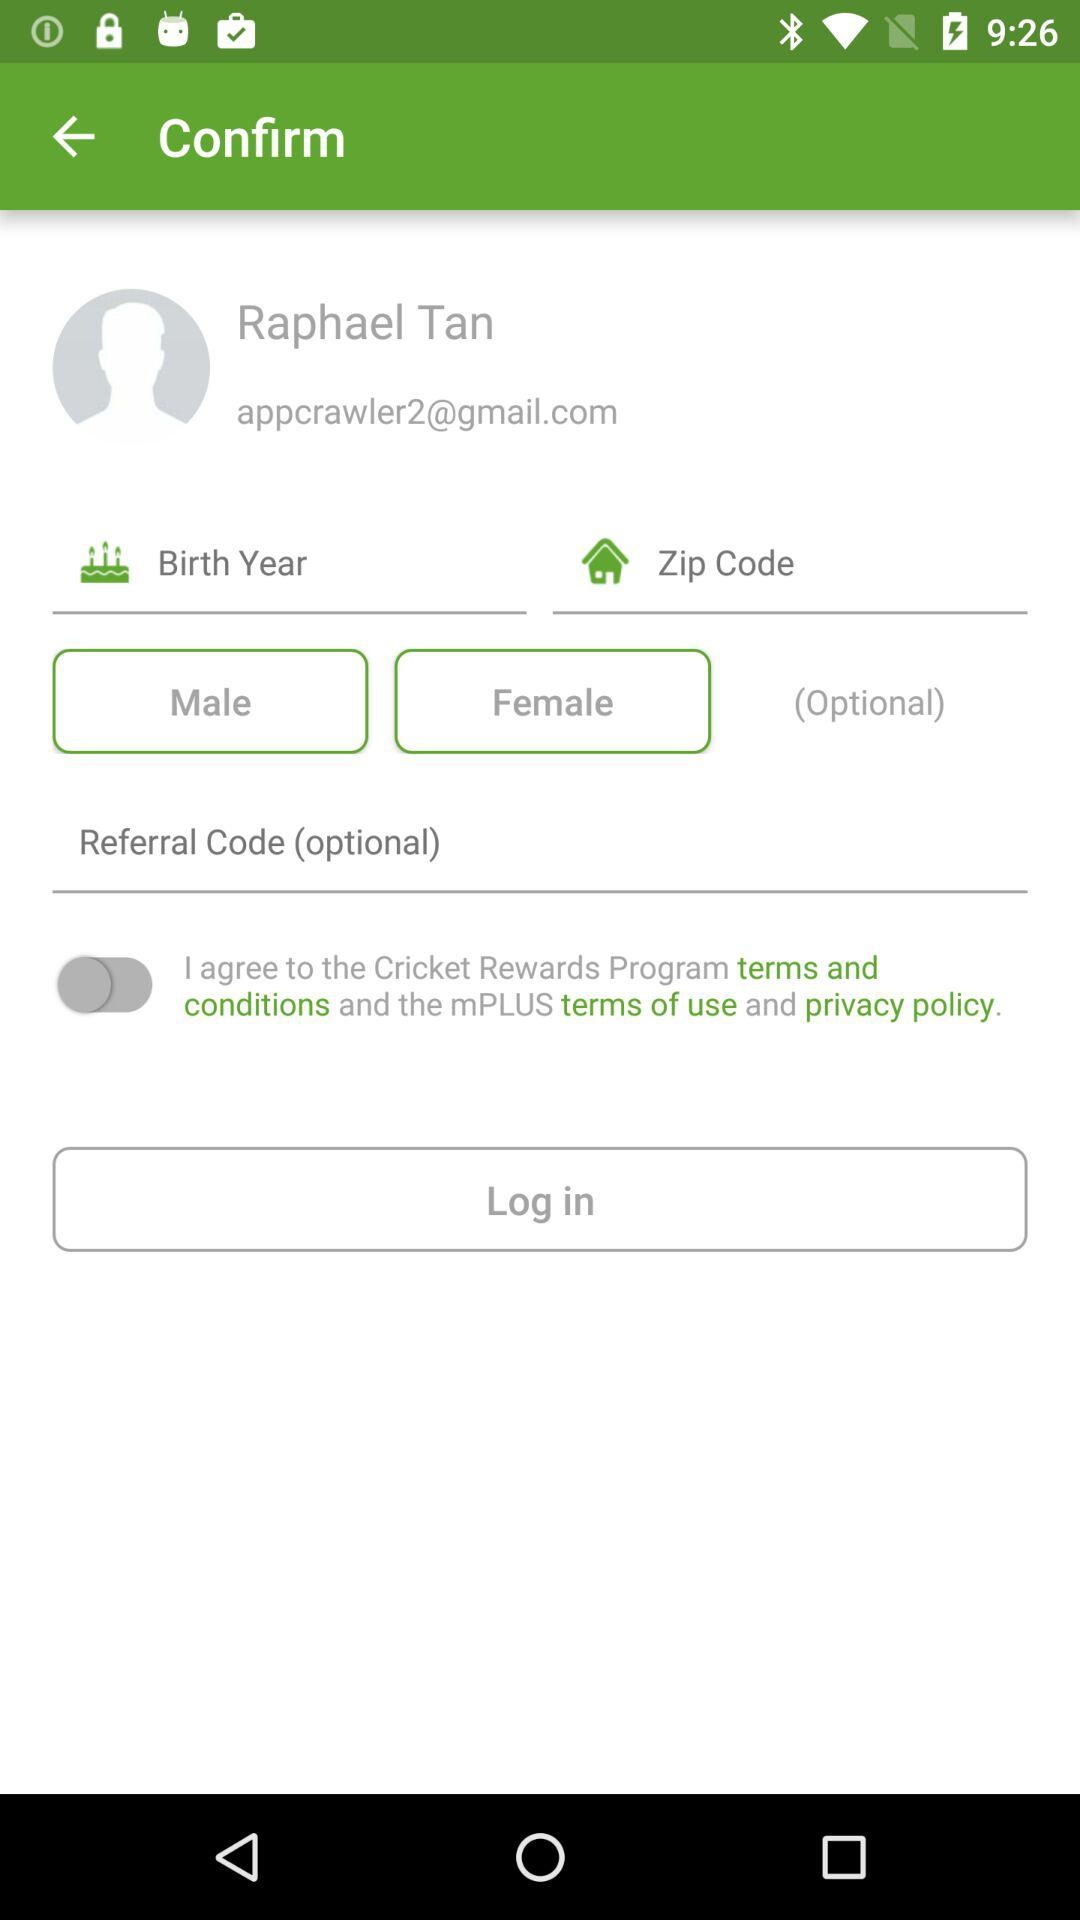What is the email address? The email address is appcrawler2@gmail.com. 